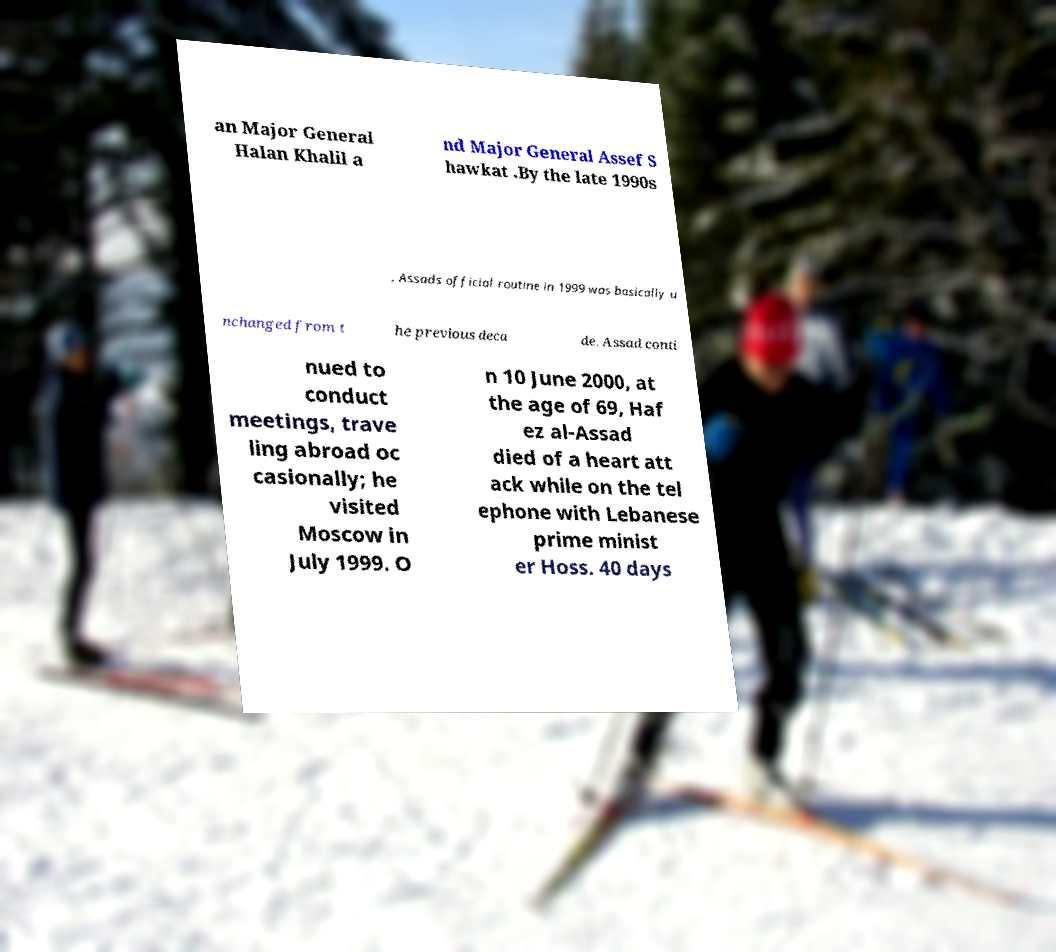Could you extract and type out the text from this image? an Major General Halan Khalil a nd Major General Assef S hawkat .By the late 1990s , Assads official routine in 1999 was basically u nchanged from t he previous deca de. Assad conti nued to conduct meetings, trave ling abroad oc casionally; he visited Moscow in July 1999. O n 10 June 2000, at the age of 69, Haf ez al-Assad died of a heart att ack while on the tel ephone with Lebanese prime minist er Hoss. 40 days 